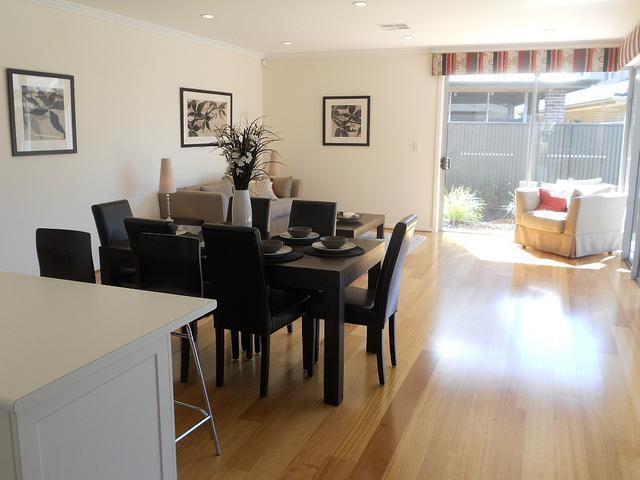What color is the seat on the couch in the corner window?
Select the accurate response from the four choices given to answer the question.
Options: Blue, white, yellow, red. White. 